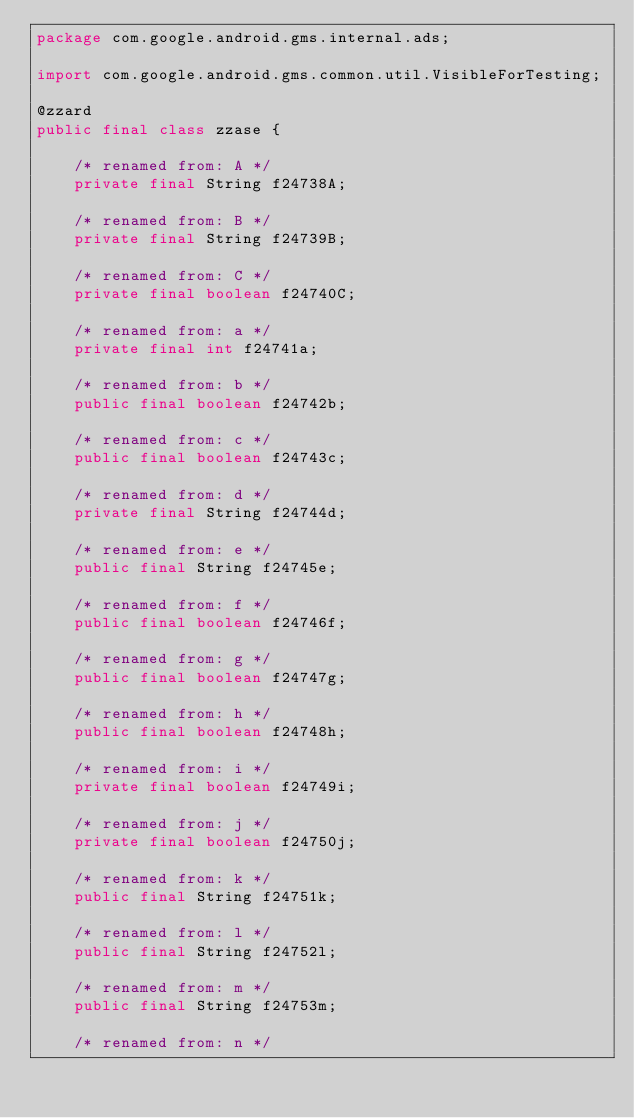Convert code to text. <code><loc_0><loc_0><loc_500><loc_500><_Java_>package com.google.android.gms.internal.ads;

import com.google.android.gms.common.util.VisibleForTesting;

@zzard
public final class zzase {

    /* renamed from: A */
    private final String f24738A;

    /* renamed from: B */
    private final String f24739B;

    /* renamed from: C */
    private final boolean f24740C;

    /* renamed from: a */
    private final int f24741a;

    /* renamed from: b */
    public final boolean f24742b;

    /* renamed from: c */
    public final boolean f24743c;

    /* renamed from: d */
    private final String f24744d;

    /* renamed from: e */
    public final String f24745e;

    /* renamed from: f */
    public final boolean f24746f;

    /* renamed from: g */
    public final boolean f24747g;

    /* renamed from: h */
    public final boolean f24748h;

    /* renamed from: i */
    private final boolean f24749i;

    /* renamed from: j */
    private final boolean f24750j;

    /* renamed from: k */
    public final String f24751k;

    /* renamed from: l */
    public final String f24752l;

    /* renamed from: m */
    public final String f24753m;

    /* renamed from: n */</code> 